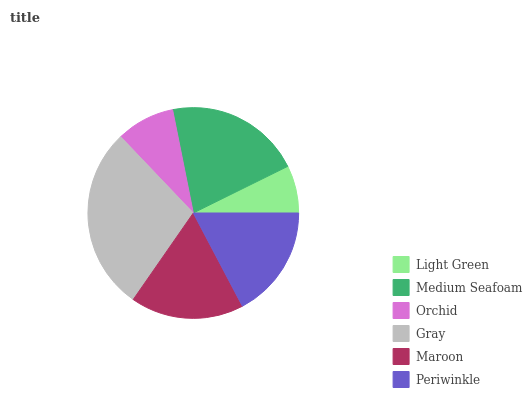Is Light Green the minimum?
Answer yes or no. Yes. Is Gray the maximum?
Answer yes or no. Yes. Is Medium Seafoam the minimum?
Answer yes or no. No. Is Medium Seafoam the maximum?
Answer yes or no. No. Is Medium Seafoam greater than Light Green?
Answer yes or no. Yes. Is Light Green less than Medium Seafoam?
Answer yes or no. Yes. Is Light Green greater than Medium Seafoam?
Answer yes or no. No. Is Medium Seafoam less than Light Green?
Answer yes or no. No. Is Maroon the high median?
Answer yes or no. Yes. Is Periwinkle the low median?
Answer yes or no. Yes. Is Periwinkle the high median?
Answer yes or no. No. Is Gray the low median?
Answer yes or no. No. 